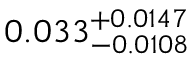<formula> <loc_0><loc_0><loc_500><loc_500>0 . 0 3 3 _ { - 0 . 0 1 0 8 } ^ { + 0 . 0 1 4 7 }</formula> 